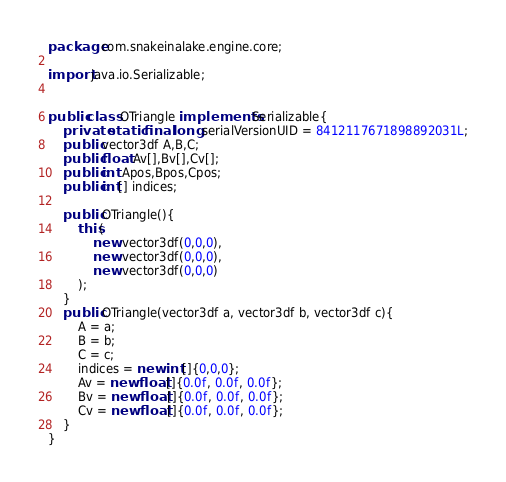Convert code to text. <code><loc_0><loc_0><loc_500><loc_500><_Java_>package com.snakeinalake.engine.core;

import java.io.Serializable;


public class OTriangle implements Serializable{
	private static final long serialVersionUID = 8412117671898892031L;
	public vector3df A,B,C;
	public float Av[],Bv[],Cv[];
	public int Apos,Bpos,Cpos;
	public int[] indices;
	
	public OTriangle(){
		this(
			new vector3df(0,0,0),
			new vector3df(0,0,0),
			new vector3df(0,0,0)
		);
	}	
	public OTriangle(vector3df a, vector3df b, vector3df c){
		A = a;
		B = b;
		C = c;
		indices = new int[]{0,0,0};
		Av = new float[]{0.0f, 0.0f, 0.0f};
		Bv = new float[]{0.0f, 0.0f, 0.0f};
		Cv = new float[]{0.0f, 0.0f, 0.0f};
	}
}
</code> 